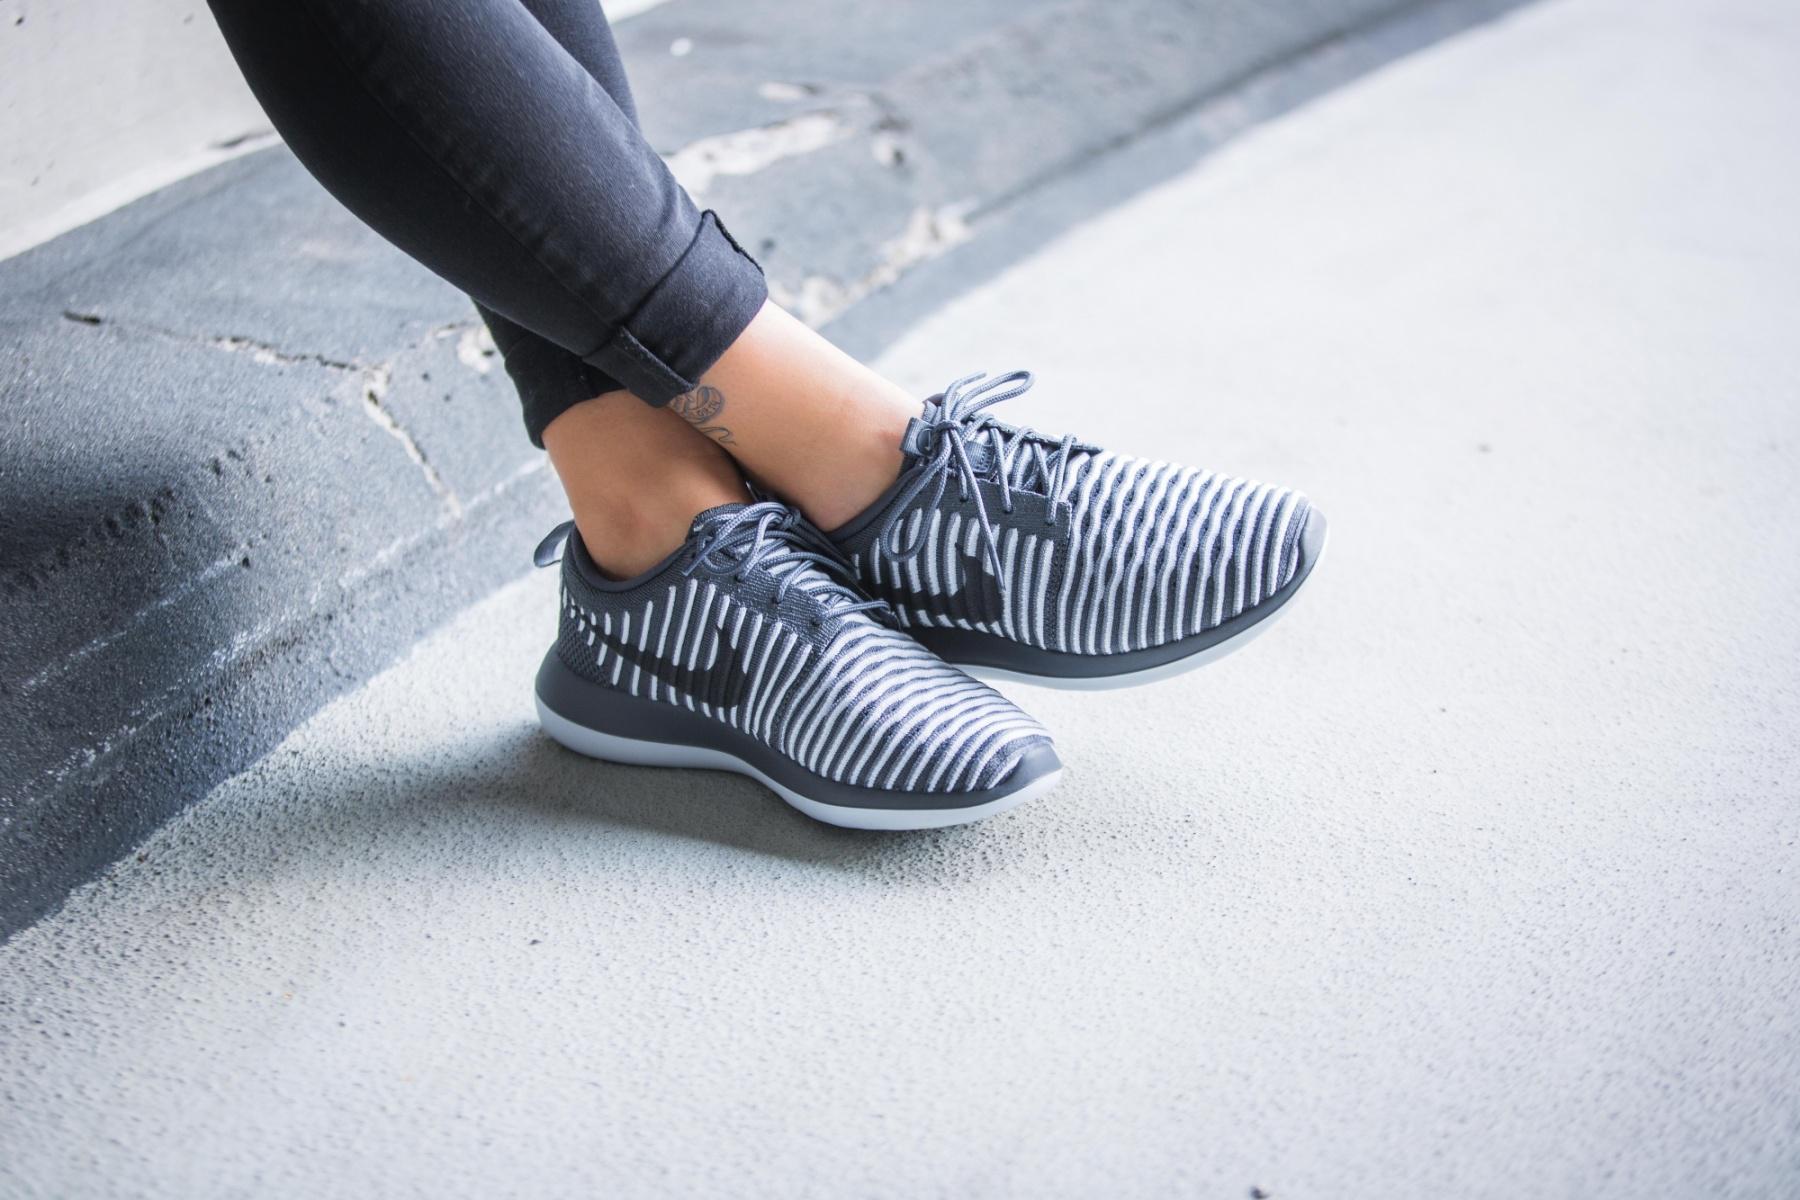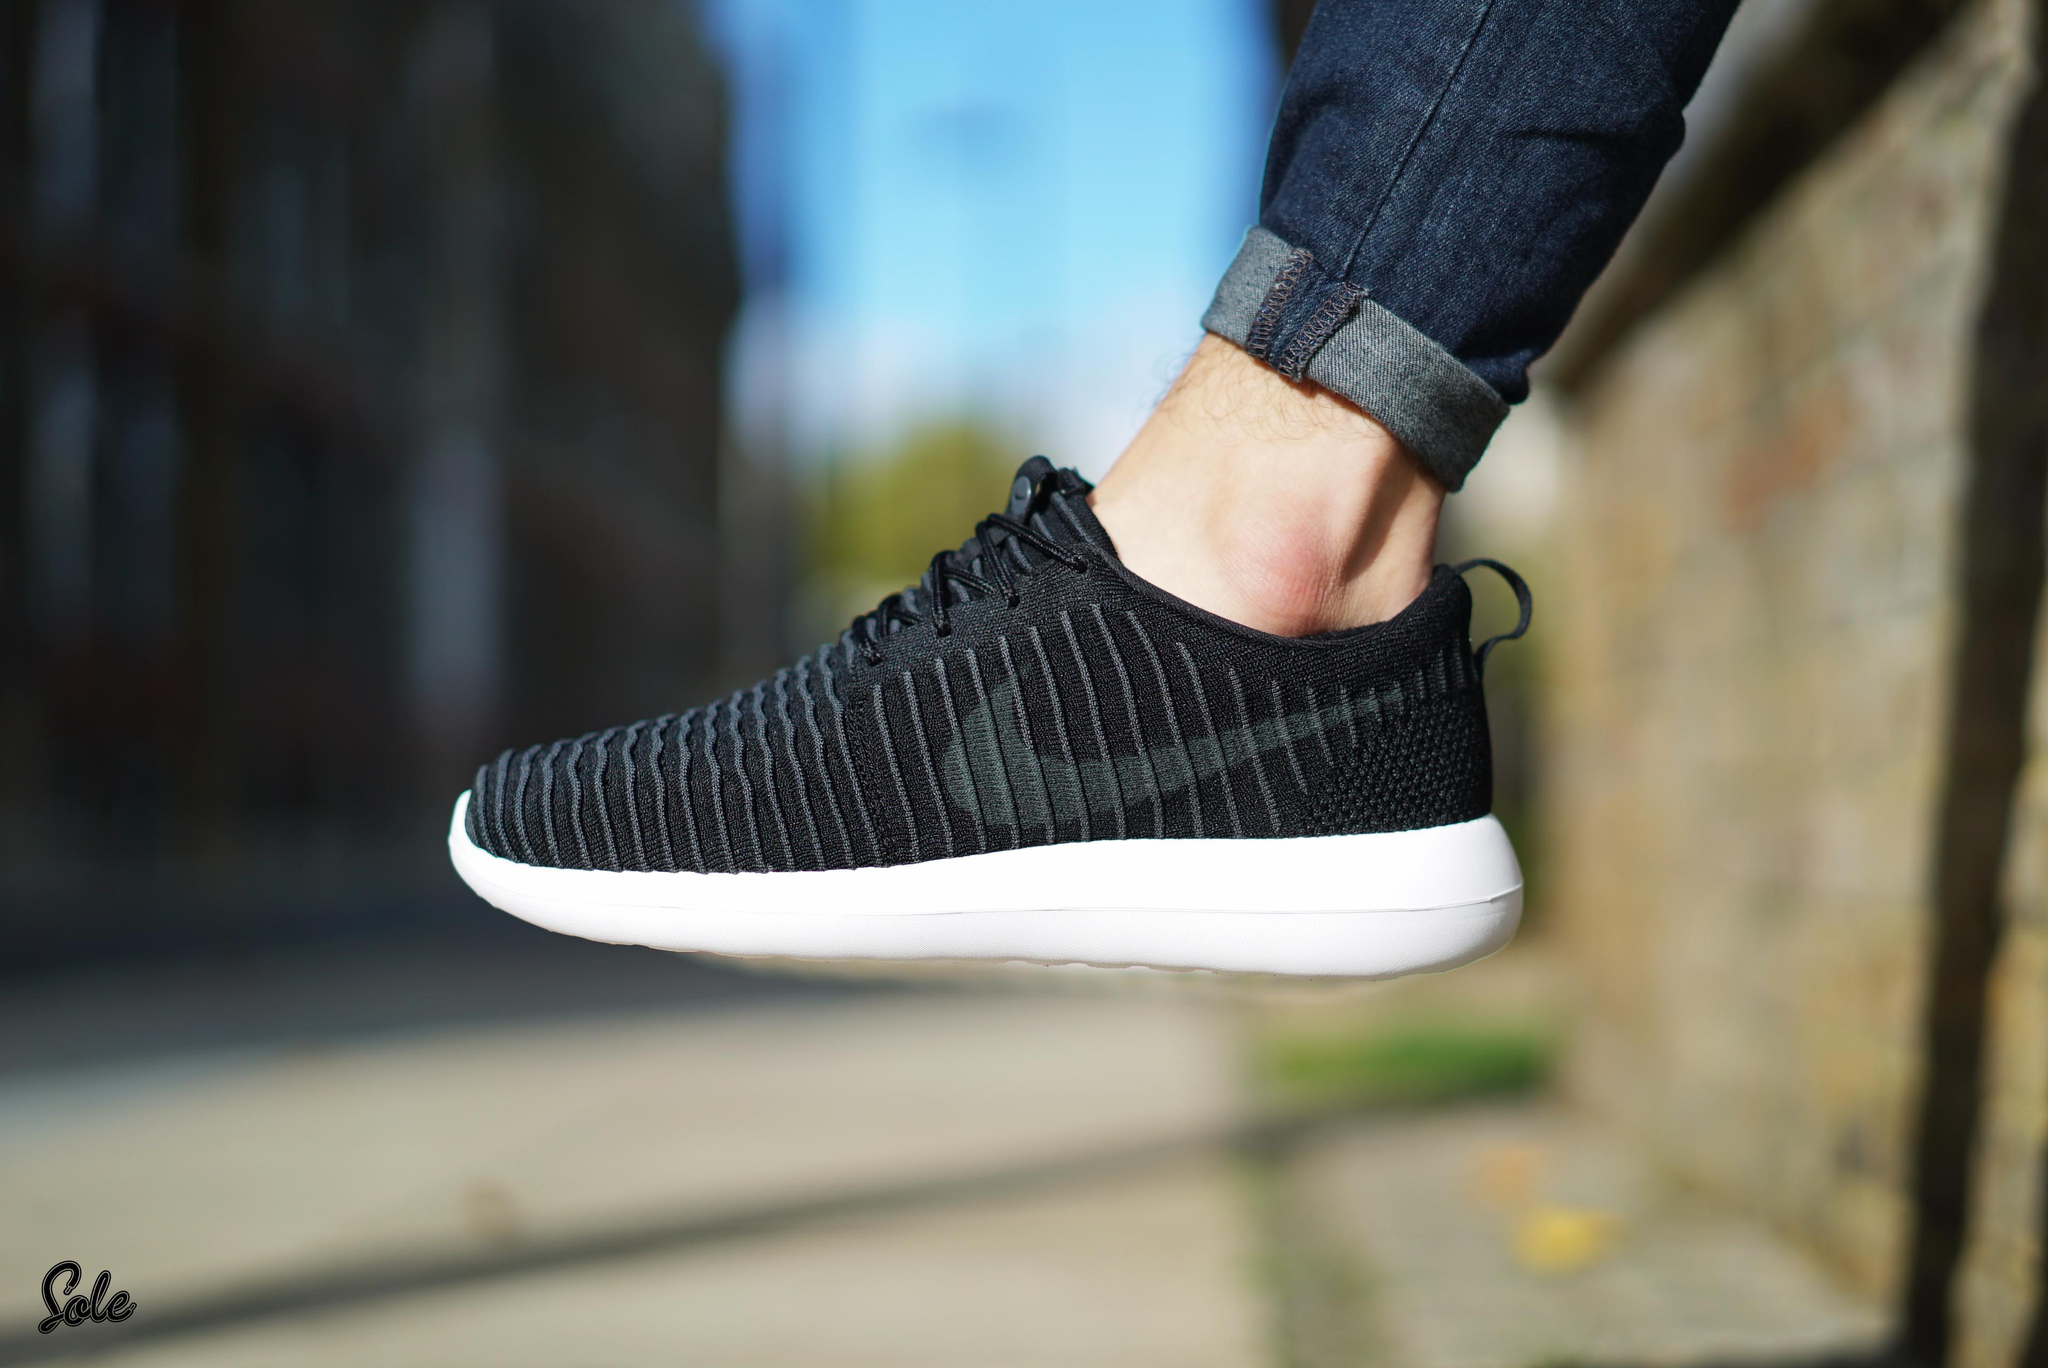The first image is the image on the left, the second image is the image on the right. For the images displayed, is the sentence "An image shows a pair of sneaker-wearing feet flat on the ground on an outdoor surface." factually correct? Answer yes or no. No. The first image is the image on the left, the second image is the image on the right. Considering the images on both sides, is "The person in the image on the left is standing with both feet planted firmly a hard surface." valid? Answer yes or no. No. 